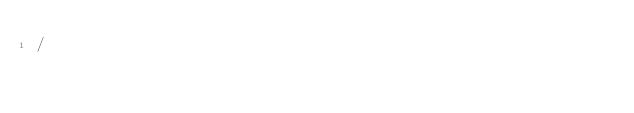<code> <loc_0><loc_0><loc_500><loc_500><_SQL_>/
</code> 